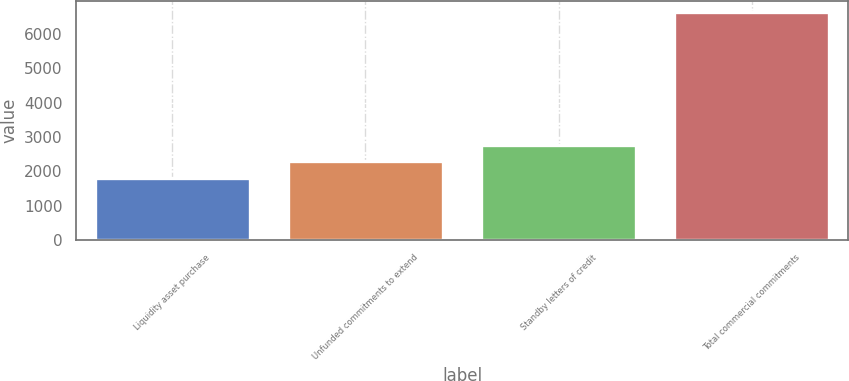<chart> <loc_0><loc_0><loc_500><loc_500><bar_chart><fcel>Liquidity asset purchase<fcel>Unfunded commitments to extend<fcel>Standby letters of credit<fcel>Total commercial commitments<nl><fcel>1813<fcel>2296<fcel>2779<fcel>6643<nl></chart> 